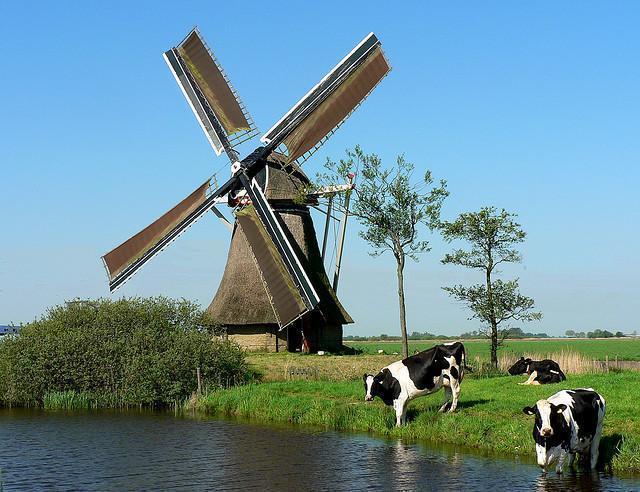What does the building do?
Answer the question by selecting the correct answer among the 4 following choices and explain your choice with a short sentence. The answer should be formatted with the following format: `Answer: choice
Rationale: rationale.`
Options: Walk, sing, spin, generate heat. Answer: spin.
Rationale: It can generate power or grind grain to make flour. 